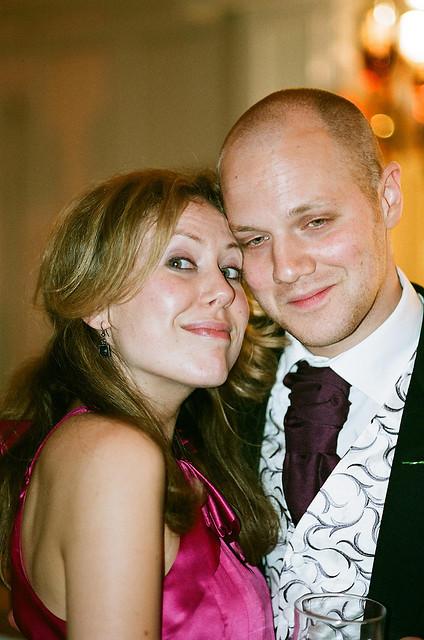Are the people a couple?
Answer briefly. Yes. Are the two people in this image of the same ethnicity?
Concise answer only. Yes. Is the girl a brunette?
Concise answer only. Yes. What pattern is the tie that the gentleman is wearing?
Concise answer only. Solid. What is the woman doing?
Write a very short answer. Smiling. What color are the stones in her earrings?
Short answer required. Black. Shouldn't the woman lose some weight?
Give a very brief answer. No. Does this woman have tan lines?
Give a very brief answer. No. Why would he be dressed like this?
Write a very short answer. Wedding. How many adults are in the photo?
Concise answer only. 2. Does it look like these people have been drinking?
Give a very brief answer. Yes. What are these people doing?
Keep it brief. Posing. 